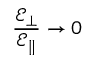Convert formula to latex. <formula><loc_0><loc_0><loc_500><loc_500>\frac { \mathcal { E } _ { \bot } } { \mathcal { E } _ { \| } } \rightarrow 0</formula> 